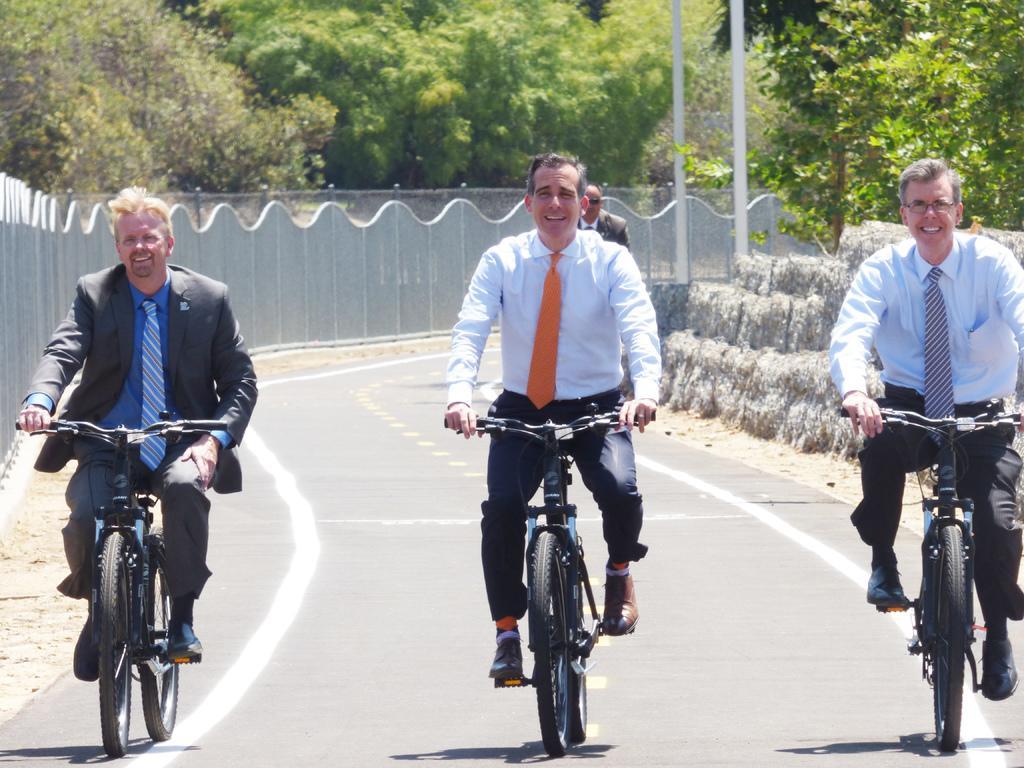Could you give a brief overview of what you see in this image? Here in this picture we can see 4 men. First three men are riding bicycle. The left side man is wearing black jacket, blue shirt and tie. The middle man is wearing a white shirt and orange tie. The right side man he is wearing a blue shirt and a tie and he is having spectacles. To the left side there are fencing, inside the fencing there are some trees. At the back side of the middle men there is men. And we can also see right middle corner there are some white color poles. 